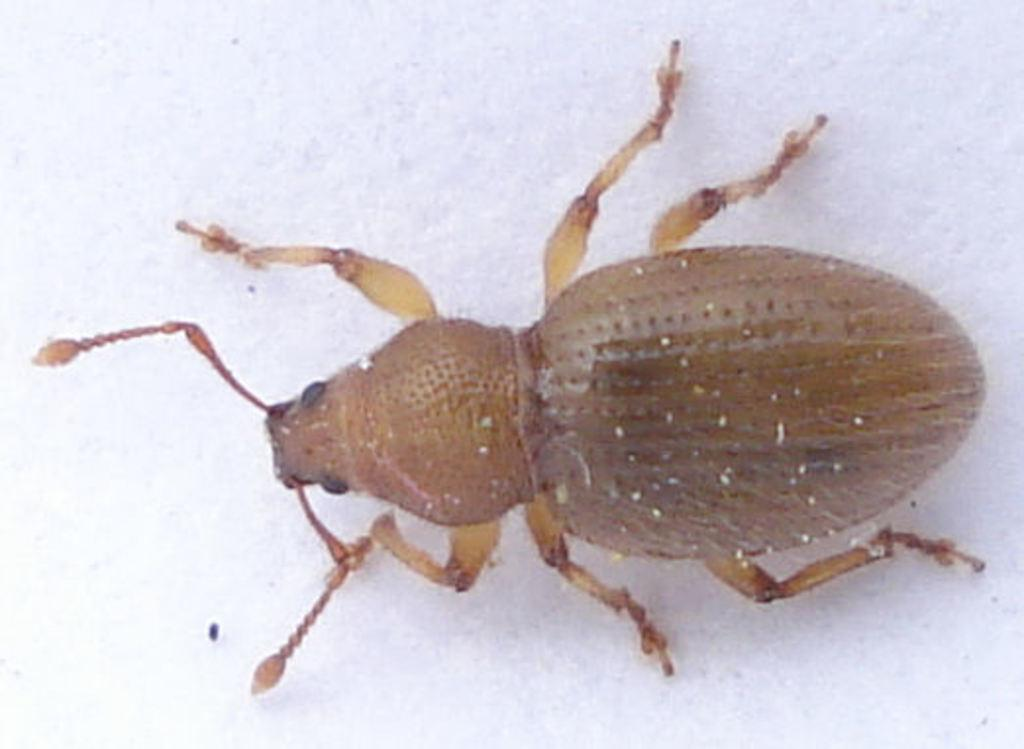What type of creature is present in the image? There is an insect in the image. What color is the insect? The insect is brown in color. What is the color of the background in the image? The background of the image is white. What type of paper can be seen in the image? There is no paper present in the image; it features an insect on a white background. Can you describe the fowl in the image? There is no fowl present in the image; it features an insect on a white background. 